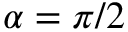<formula> <loc_0><loc_0><loc_500><loc_500>\alpha = \pi / 2</formula> 